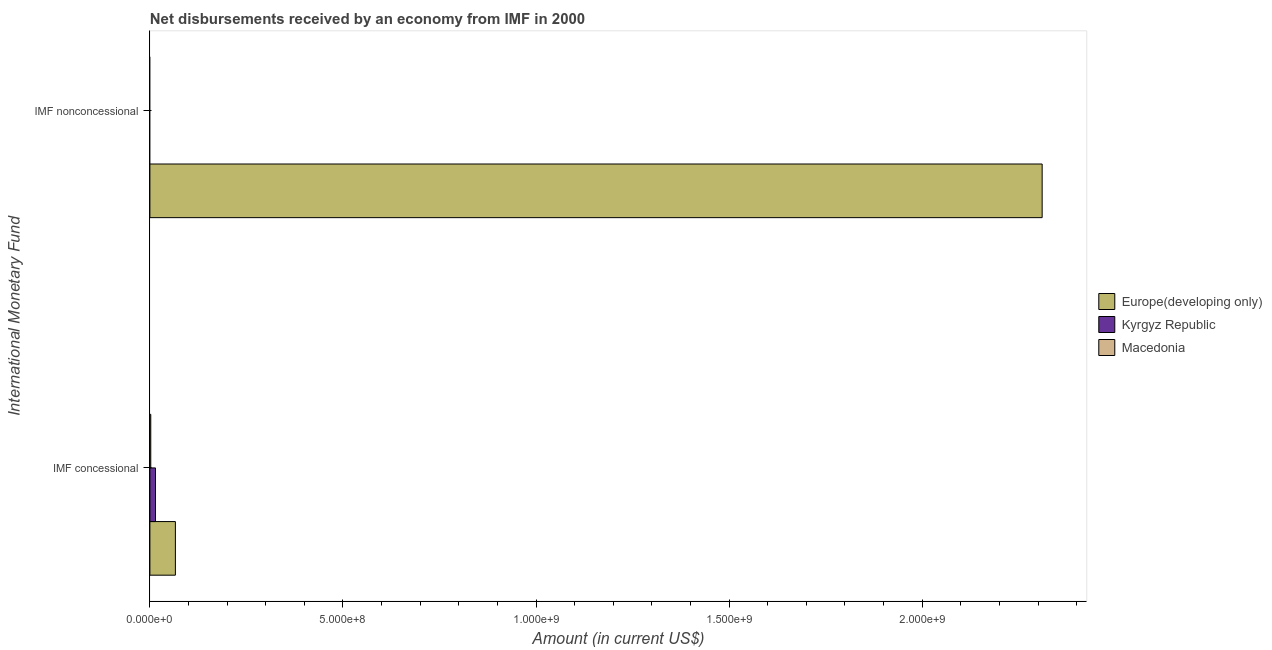How many different coloured bars are there?
Make the answer very short. 3. Are the number of bars per tick equal to the number of legend labels?
Ensure brevity in your answer.  No. What is the label of the 2nd group of bars from the top?
Your response must be concise. IMF concessional. What is the net concessional disbursements from imf in Europe(developing only)?
Your answer should be compact. 6.60e+07. Across all countries, what is the maximum net concessional disbursements from imf?
Keep it short and to the point. 6.60e+07. Across all countries, what is the minimum net non concessional disbursements from imf?
Offer a terse response. 0. In which country was the net concessional disbursements from imf maximum?
Provide a short and direct response. Europe(developing only). What is the total net concessional disbursements from imf in the graph?
Your answer should be very brief. 8.28e+07. What is the difference between the net concessional disbursements from imf in Kyrgyz Republic and that in Europe(developing only)?
Give a very brief answer. -5.15e+07. What is the difference between the net concessional disbursements from imf in Europe(developing only) and the net non concessional disbursements from imf in Kyrgyz Republic?
Provide a short and direct response. 6.60e+07. What is the average net non concessional disbursements from imf per country?
Your response must be concise. 7.70e+08. What is the difference between the net concessional disbursements from imf and net non concessional disbursements from imf in Europe(developing only)?
Your response must be concise. -2.24e+09. In how many countries, is the net non concessional disbursements from imf greater than 1800000000 US$?
Offer a very short reply. 1. What is the ratio of the net concessional disbursements from imf in Macedonia to that in Kyrgyz Republic?
Offer a terse response. 0.16. Is the net concessional disbursements from imf in Kyrgyz Republic less than that in Macedonia?
Ensure brevity in your answer.  No. How many bars are there?
Your response must be concise. 4. What is the difference between two consecutive major ticks on the X-axis?
Make the answer very short. 5.00e+08. Are the values on the major ticks of X-axis written in scientific E-notation?
Your answer should be very brief. Yes. Does the graph contain any zero values?
Offer a very short reply. Yes. Where does the legend appear in the graph?
Offer a very short reply. Center right. How are the legend labels stacked?
Provide a succinct answer. Vertical. What is the title of the graph?
Your answer should be very brief. Net disbursements received by an economy from IMF in 2000. Does "Sub-Saharan Africa (all income levels)" appear as one of the legend labels in the graph?
Keep it short and to the point. No. What is the label or title of the Y-axis?
Offer a very short reply. International Monetary Fund. What is the Amount (in current US$) of Europe(developing only) in IMF concessional?
Your response must be concise. 6.60e+07. What is the Amount (in current US$) in Kyrgyz Republic in IMF concessional?
Keep it short and to the point. 1.45e+07. What is the Amount (in current US$) of Macedonia in IMF concessional?
Your response must be concise. 2.27e+06. What is the Amount (in current US$) in Europe(developing only) in IMF nonconcessional?
Keep it short and to the point. 2.31e+09. Across all International Monetary Fund, what is the maximum Amount (in current US$) in Europe(developing only)?
Your answer should be compact. 2.31e+09. Across all International Monetary Fund, what is the maximum Amount (in current US$) of Kyrgyz Republic?
Ensure brevity in your answer.  1.45e+07. Across all International Monetary Fund, what is the maximum Amount (in current US$) of Macedonia?
Your answer should be compact. 2.27e+06. Across all International Monetary Fund, what is the minimum Amount (in current US$) of Europe(developing only)?
Your answer should be compact. 6.60e+07. Across all International Monetary Fund, what is the minimum Amount (in current US$) of Kyrgyz Republic?
Make the answer very short. 0. Across all International Monetary Fund, what is the minimum Amount (in current US$) of Macedonia?
Your response must be concise. 0. What is the total Amount (in current US$) in Europe(developing only) in the graph?
Offer a very short reply. 2.38e+09. What is the total Amount (in current US$) of Kyrgyz Republic in the graph?
Your response must be concise. 1.45e+07. What is the total Amount (in current US$) in Macedonia in the graph?
Provide a short and direct response. 2.27e+06. What is the difference between the Amount (in current US$) in Europe(developing only) in IMF concessional and that in IMF nonconcessional?
Provide a succinct answer. -2.24e+09. What is the average Amount (in current US$) in Europe(developing only) per International Monetary Fund?
Your response must be concise. 1.19e+09. What is the average Amount (in current US$) of Kyrgyz Republic per International Monetary Fund?
Ensure brevity in your answer.  7.25e+06. What is the average Amount (in current US$) in Macedonia per International Monetary Fund?
Your response must be concise. 1.14e+06. What is the difference between the Amount (in current US$) in Europe(developing only) and Amount (in current US$) in Kyrgyz Republic in IMF concessional?
Ensure brevity in your answer.  5.15e+07. What is the difference between the Amount (in current US$) of Europe(developing only) and Amount (in current US$) of Macedonia in IMF concessional?
Offer a very short reply. 6.38e+07. What is the difference between the Amount (in current US$) in Kyrgyz Republic and Amount (in current US$) in Macedonia in IMF concessional?
Provide a short and direct response. 1.22e+07. What is the ratio of the Amount (in current US$) in Europe(developing only) in IMF concessional to that in IMF nonconcessional?
Keep it short and to the point. 0.03. What is the difference between the highest and the second highest Amount (in current US$) of Europe(developing only)?
Your answer should be compact. 2.24e+09. What is the difference between the highest and the lowest Amount (in current US$) in Europe(developing only)?
Give a very brief answer. 2.24e+09. What is the difference between the highest and the lowest Amount (in current US$) in Kyrgyz Republic?
Provide a short and direct response. 1.45e+07. What is the difference between the highest and the lowest Amount (in current US$) of Macedonia?
Offer a very short reply. 2.27e+06. 